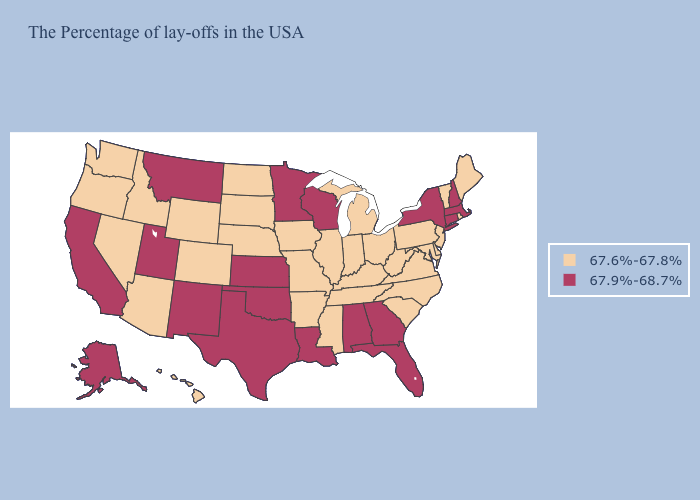Does the first symbol in the legend represent the smallest category?
Short answer required. Yes. What is the highest value in states that border North Dakota?
Keep it brief. 67.9%-68.7%. What is the lowest value in the USA?
Give a very brief answer. 67.6%-67.8%. Name the states that have a value in the range 67.9%-68.7%?
Concise answer only. Massachusetts, New Hampshire, Connecticut, New York, Florida, Georgia, Alabama, Wisconsin, Louisiana, Minnesota, Kansas, Oklahoma, Texas, New Mexico, Utah, Montana, California, Alaska. What is the highest value in the USA?
Give a very brief answer. 67.9%-68.7%. What is the value of New York?
Keep it brief. 67.9%-68.7%. Among the states that border New Hampshire , does Massachusetts have the lowest value?
Give a very brief answer. No. Name the states that have a value in the range 67.6%-67.8%?
Keep it brief. Maine, Rhode Island, Vermont, New Jersey, Delaware, Maryland, Pennsylvania, Virginia, North Carolina, South Carolina, West Virginia, Ohio, Michigan, Kentucky, Indiana, Tennessee, Illinois, Mississippi, Missouri, Arkansas, Iowa, Nebraska, South Dakota, North Dakota, Wyoming, Colorado, Arizona, Idaho, Nevada, Washington, Oregon, Hawaii. Name the states that have a value in the range 67.6%-67.8%?
Concise answer only. Maine, Rhode Island, Vermont, New Jersey, Delaware, Maryland, Pennsylvania, Virginia, North Carolina, South Carolina, West Virginia, Ohio, Michigan, Kentucky, Indiana, Tennessee, Illinois, Mississippi, Missouri, Arkansas, Iowa, Nebraska, South Dakota, North Dakota, Wyoming, Colorado, Arizona, Idaho, Nevada, Washington, Oregon, Hawaii. Which states have the highest value in the USA?
Concise answer only. Massachusetts, New Hampshire, Connecticut, New York, Florida, Georgia, Alabama, Wisconsin, Louisiana, Minnesota, Kansas, Oklahoma, Texas, New Mexico, Utah, Montana, California, Alaska. Name the states that have a value in the range 67.6%-67.8%?
Short answer required. Maine, Rhode Island, Vermont, New Jersey, Delaware, Maryland, Pennsylvania, Virginia, North Carolina, South Carolina, West Virginia, Ohio, Michigan, Kentucky, Indiana, Tennessee, Illinois, Mississippi, Missouri, Arkansas, Iowa, Nebraska, South Dakota, North Dakota, Wyoming, Colorado, Arizona, Idaho, Nevada, Washington, Oregon, Hawaii. How many symbols are there in the legend?
Quick response, please. 2. Name the states that have a value in the range 67.6%-67.8%?
Keep it brief. Maine, Rhode Island, Vermont, New Jersey, Delaware, Maryland, Pennsylvania, Virginia, North Carolina, South Carolina, West Virginia, Ohio, Michigan, Kentucky, Indiana, Tennessee, Illinois, Mississippi, Missouri, Arkansas, Iowa, Nebraska, South Dakota, North Dakota, Wyoming, Colorado, Arizona, Idaho, Nevada, Washington, Oregon, Hawaii. Name the states that have a value in the range 67.9%-68.7%?
Concise answer only. Massachusetts, New Hampshire, Connecticut, New York, Florida, Georgia, Alabama, Wisconsin, Louisiana, Minnesota, Kansas, Oklahoma, Texas, New Mexico, Utah, Montana, California, Alaska. Name the states that have a value in the range 67.6%-67.8%?
Concise answer only. Maine, Rhode Island, Vermont, New Jersey, Delaware, Maryland, Pennsylvania, Virginia, North Carolina, South Carolina, West Virginia, Ohio, Michigan, Kentucky, Indiana, Tennessee, Illinois, Mississippi, Missouri, Arkansas, Iowa, Nebraska, South Dakota, North Dakota, Wyoming, Colorado, Arizona, Idaho, Nevada, Washington, Oregon, Hawaii. 